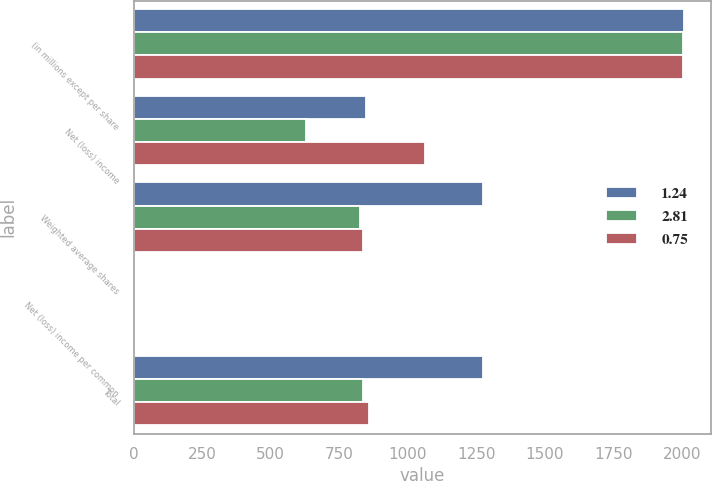<chart> <loc_0><loc_0><loc_500><loc_500><stacked_bar_chart><ecel><fcel>(in millions except per share<fcel>Net (loss) income<fcel>Weighted average shares<fcel>Net (loss) income per common<fcel>Total<nl><fcel>1.24<fcel>2006<fcel>847.95<fcel>1273.7<fcel>2.81<fcel>1273.7<nl><fcel>2.81<fcel>2005<fcel>628<fcel>825.8<fcel>0.76<fcel>837.6<nl><fcel>0.75<fcel>2004<fcel>1062<fcel>838.2<fcel>1.27<fcel>857.7<nl></chart> 